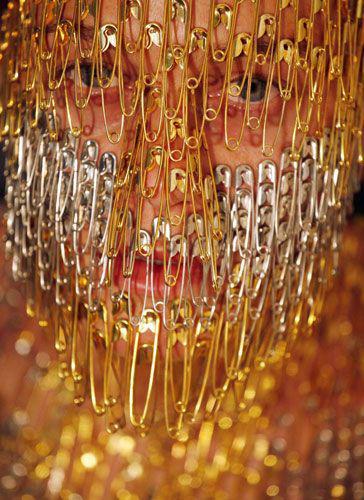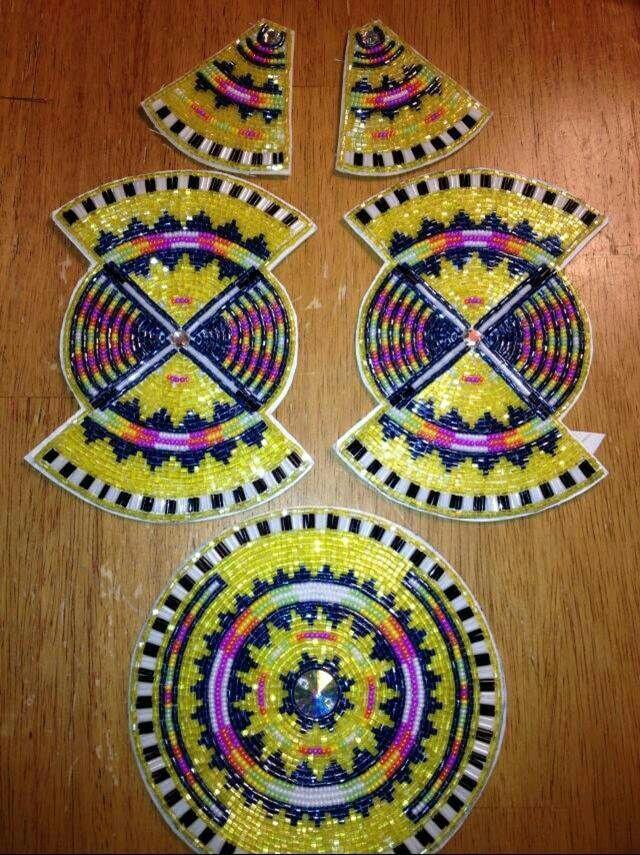The first image is the image on the left, the second image is the image on the right. Assess this claim about the two images: "An image shows flat beaded items in geometric shapes.". Correct or not? Answer yes or no. Yes. 